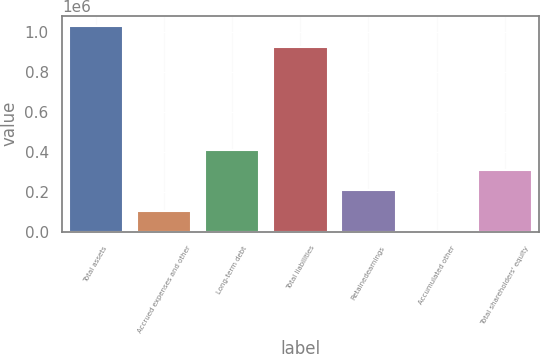Convert chart. <chart><loc_0><loc_0><loc_500><loc_500><bar_chart><fcel>Total assets<fcel>Accrued expenses and other<fcel>Long-term debt<fcel>Total liabilities<fcel>Retainedearnings<fcel>Accumulated other<fcel>Total shareholders' equity<nl><fcel>1.031e+06<fcel>105949<fcel>412210<fcel>928910<fcel>208036<fcel>3862<fcel>310123<nl></chart> 